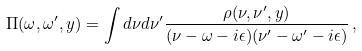Convert formula to latex. <formula><loc_0><loc_0><loc_500><loc_500>\Pi ( \omega , \omega ^ { \prime } , y ) = \int d \nu d \nu ^ { \prime } { \frac { \rho ( \nu , \nu ^ { \prime } , y ) } { ( \nu - \omega - i \epsilon ) ( \nu ^ { \prime } - \omega ^ { \prime } - i \epsilon ) } } \, ,</formula> 